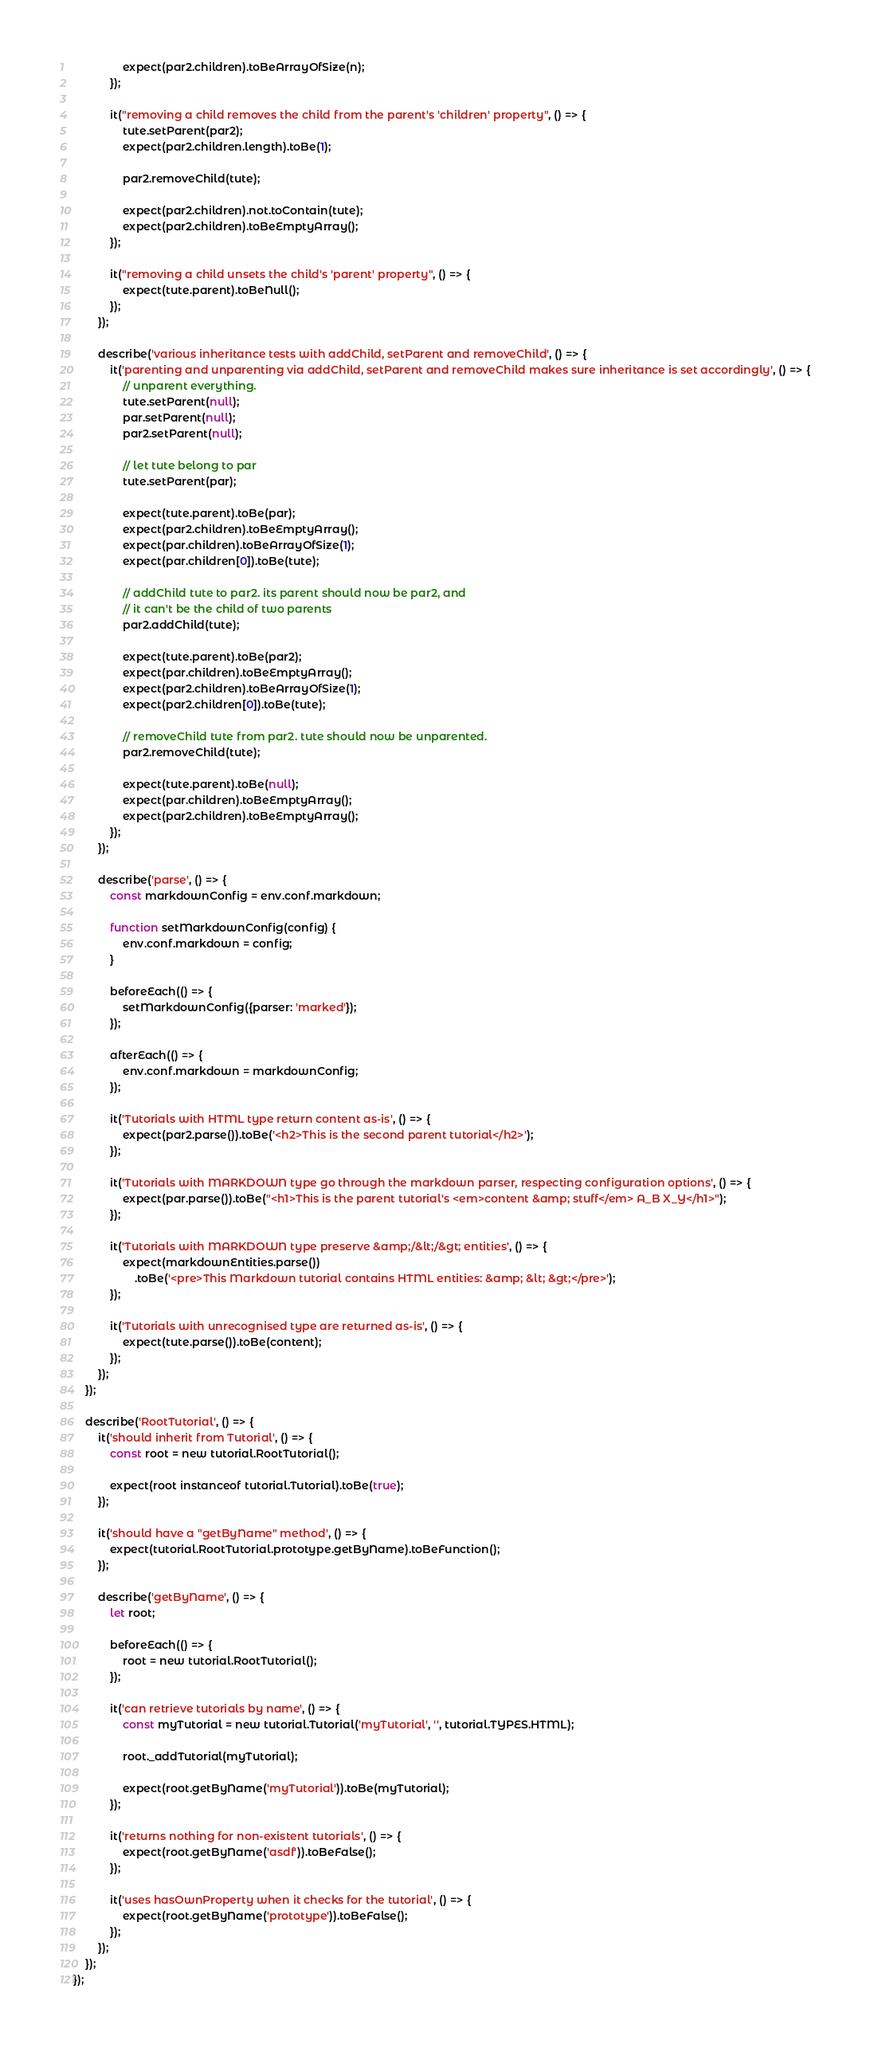<code> <loc_0><loc_0><loc_500><loc_500><_JavaScript_>                expect(par2.children).toBeArrayOfSize(n);
            });

            it("removing a child removes the child from the parent's 'children' property", () => {
                tute.setParent(par2);
                expect(par2.children.length).toBe(1);

                par2.removeChild(tute);

                expect(par2.children).not.toContain(tute);
                expect(par2.children).toBeEmptyArray();
            });

            it("removing a child unsets the child's 'parent' property", () => {
                expect(tute.parent).toBeNull();
            });
        });

        describe('various inheritance tests with addChild, setParent and removeChild', () => {
            it('parenting and unparenting via addChild, setParent and removeChild makes sure inheritance is set accordingly', () => {
                // unparent everything.
                tute.setParent(null);
                par.setParent(null);
                par2.setParent(null);

                // let tute belong to par
                tute.setParent(par);

                expect(tute.parent).toBe(par);
                expect(par2.children).toBeEmptyArray();
                expect(par.children).toBeArrayOfSize(1);
                expect(par.children[0]).toBe(tute);

                // addChild tute to par2. its parent should now be par2, and
                // it can't be the child of two parents
                par2.addChild(tute);

                expect(tute.parent).toBe(par2);
                expect(par.children).toBeEmptyArray();
                expect(par2.children).toBeArrayOfSize(1);
                expect(par2.children[0]).toBe(tute);

                // removeChild tute from par2. tute should now be unparented.
                par2.removeChild(tute);

                expect(tute.parent).toBe(null);
                expect(par.children).toBeEmptyArray();
                expect(par2.children).toBeEmptyArray();
            });
        });

        describe('parse', () => {
            const markdownConfig = env.conf.markdown;

            function setMarkdownConfig(config) {
                env.conf.markdown = config;
            }

            beforeEach(() => {
                setMarkdownConfig({parser: 'marked'});
            });

            afterEach(() => {
                env.conf.markdown = markdownConfig;
            });

            it('Tutorials with HTML type return content as-is', () => {
                expect(par2.parse()).toBe('<h2>This is the second parent tutorial</h2>');
            });

            it('Tutorials with MARKDOWN type go through the markdown parser, respecting configuration options', () => {
                expect(par.parse()).toBe("<h1>This is the parent tutorial's <em>content &amp; stuff</em> A_B X_Y</h1>");
            });

            it('Tutorials with MARKDOWN type preserve &amp;/&lt;/&gt; entities', () => {
                expect(markdownEntities.parse())
                    .toBe('<pre>This Markdown tutorial contains HTML entities: &amp; &lt; &gt;</pre>');
            });

            it('Tutorials with unrecognised type are returned as-is', () => {
                expect(tute.parse()).toBe(content);
            });
        });
    });

    describe('RootTutorial', () => {
        it('should inherit from Tutorial', () => {
            const root = new tutorial.RootTutorial();

            expect(root instanceof tutorial.Tutorial).toBe(true);
        });

        it('should have a "getByName" method', () => {
            expect(tutorial.RootTutorial.prototype.getByName).toBeFunction();
        });

        describe('getByName', () => {
            let root;

            beforeEach(() => {
                root = new tutorial.RootTutorial();
            });

            it('can retrieve tutorials by name', () => {
                const myTutorial = new tutorial.Tutorial('myTutorial', '', tutorial.TYPES.HTML);

                root._addTutorial(myTutorial);

                expect(root.getByName('myTutorial')).toBe(myTutorial);
            });

            it('returns nothing for non-existent tutorials', () => {
                expect(root.getByName('asdf')).toBeFalse();
            });

            it('uses hasOwnProperty when it checks for the tutorial', () => {
                expect(root.getByName('prototype')).toBeFalse();
            });
        });
    });
});
</code> 